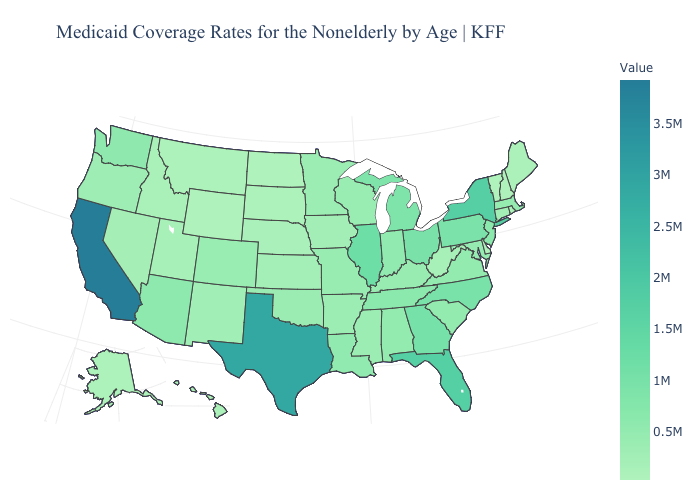Does the map have missing data?
Quick response, please. No. Does Illinois have the highest value in the MidWest?
Be succinct. Yes. Among the states that border Michigan , which have the lowest value?
Keep it brief. Wisconsin. Which states have the highest value in the USA?
Write a very short answer. California. 